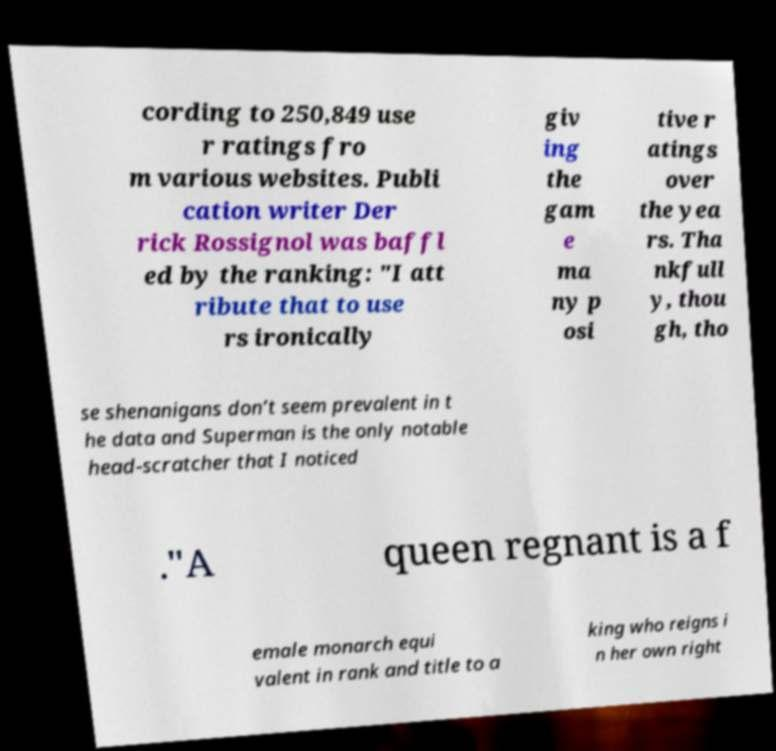Please read and relay the text visible in this image. What does it say? cording to 250,849 use r ratings fro m various websites. Publi cation writer Der rick Rossignol was baffl ed by the ranking: "I att ribute that to use rs ironically giv ing the gam e ma ny p osi tive r atings over the yea rs. Tha nkfull y, thou gh, tho se shenanigans don’t seem prevalent in t he data and Superman is the only notable head-scratcher that I noticed ."A queen regnant is a f emale monarch equi valent in rank and title to a king who reigns i n her own right 